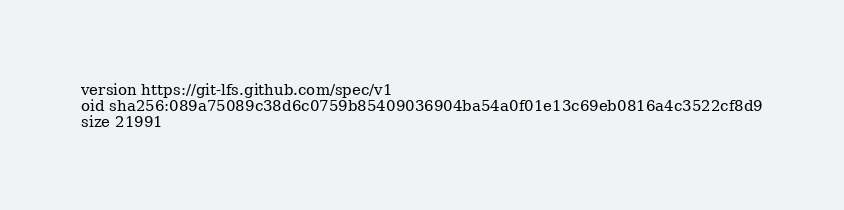<code> <loc_0><loc_0><loc_500><loc_500><_HTML_>version https://git-lfs.github.com/spec/v1
oid sha256:089a75089c38d6c0759b85409036904ba54a0f01e13c69eb0816a4c3522cf8d9
size 21991
</code> 